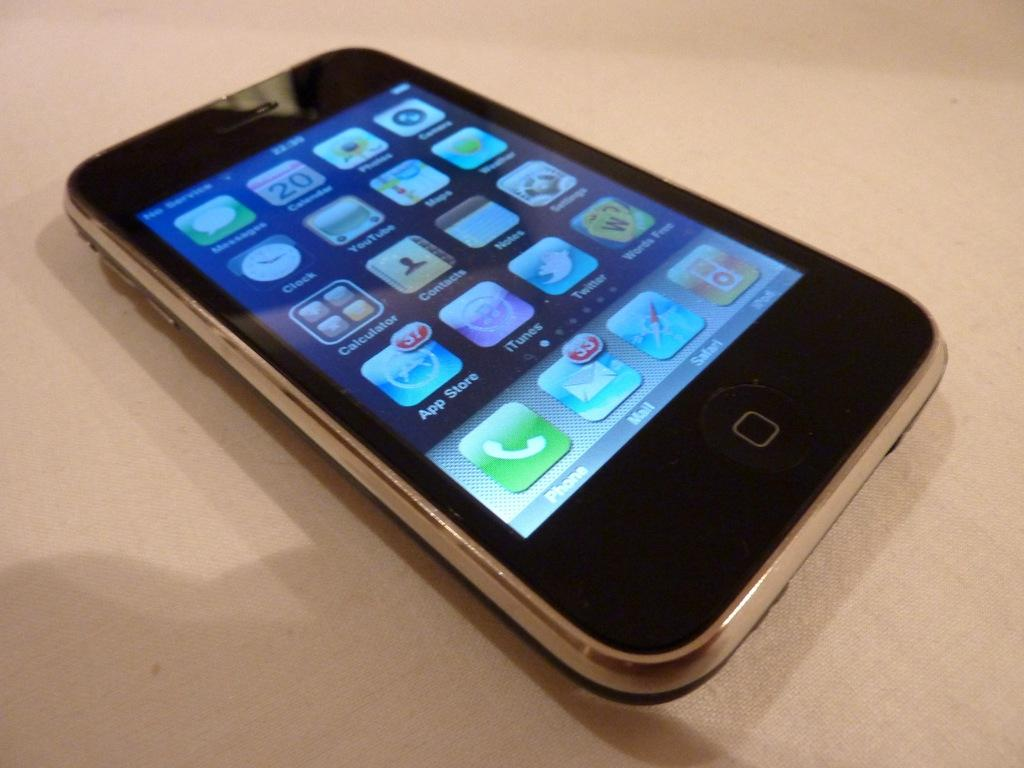<image>
Create a compact narrative representing the image presented. An iphone with several apps, the second from top left having the number 20. 